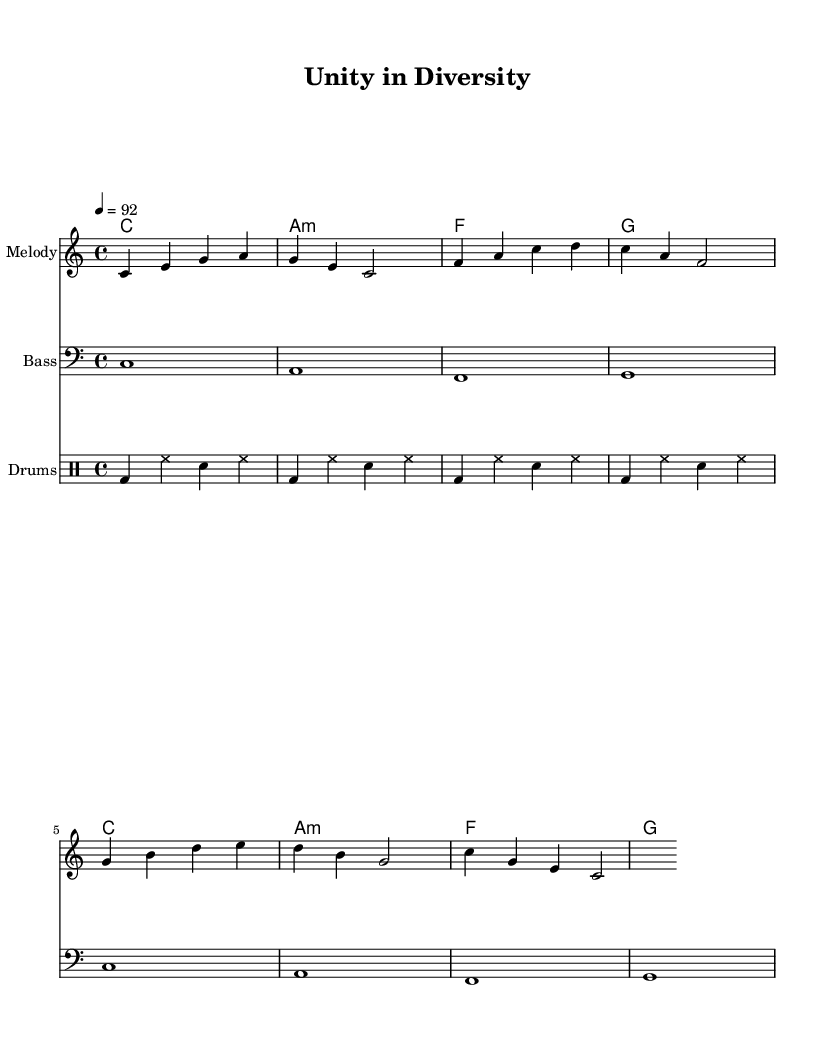What is the key signature of this music? The key signature is C major, which has no sharps or flats.
Answer: C major What is the time signature of the piece? The time signature is in 4/4, meaning there are four beats per measure.
Answer: 4/4 What is the tempo marking for this piece? The tempo marking indicates a speed of 92 beats per minute, as shown at the beginning of the score.
Answer: 92 How many different chord types are present in the harmonies? There are three different chord types: C, A minor, and F major, as indicated in the chord names section.
Answer: Three Which instrument plays the melody in this score? The melody is played by the staff labeled "Melody," which typically indicates a higher-pitched instrument like a flute or a lead vocal in rap music.
Answer: Melody What is the rhythmic pattern in the drum section? The drum section uses a repeated pattern of bass drum, hi-hat, and snare in a specific order, demonstrating a traditional hip-hop beat.
Answer: Repeated Is the song structure typical for rap music? Yes, the song structure includes a groove-driven beat along with a melodic hook, which is characteristic of clean hip-hop celebrating diversity and inclusion.
Answer: Yes 